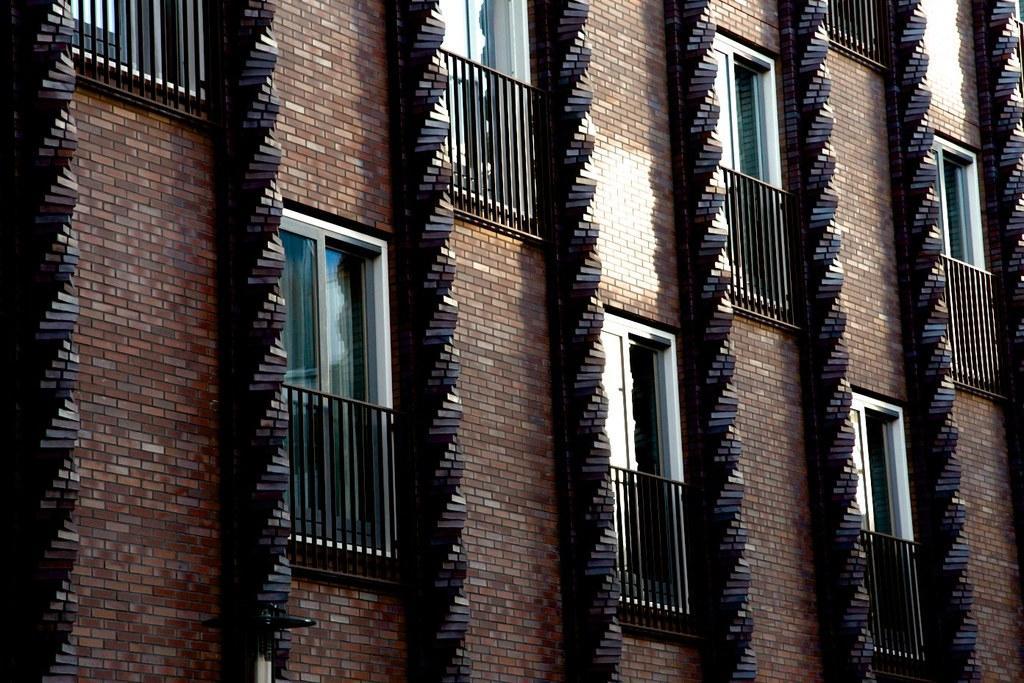How would you summarize this image in a sentence or two? In this image we can see a wall with few windows and grilles. 